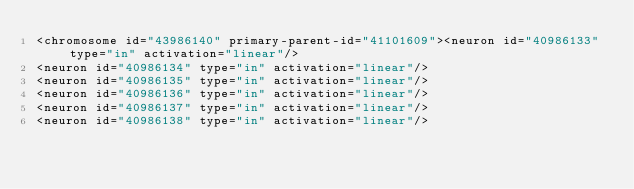Convert code to text. <code><loc_0><loc_0><loc_500><loc_500><_XML_><chromosome id="43986140" primary-parent-id="41101609"><neuron id="40986133" type="in" activation="linear"/>
<neuron id="40986134" type="in" activation="linear"/>
<neuron id="40986135" type="in" activation="linear"/>
<neuron id="40986136" type="in" activation="linear"/>
<neuron id="40986137" type="in" activation="linear"/>
<neuron id="40986138" type="in" activation="linear"/></code> 